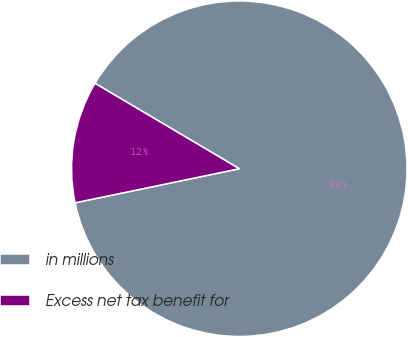Convert chart to OTSL. <chart><loc_0><loc_0><loc_500><loc_500><pie_chart><fcel>in millions<fcel>Excess net tax benefit for<nl><fcel>88.24%<fcel>11.76%<nl></chart> 